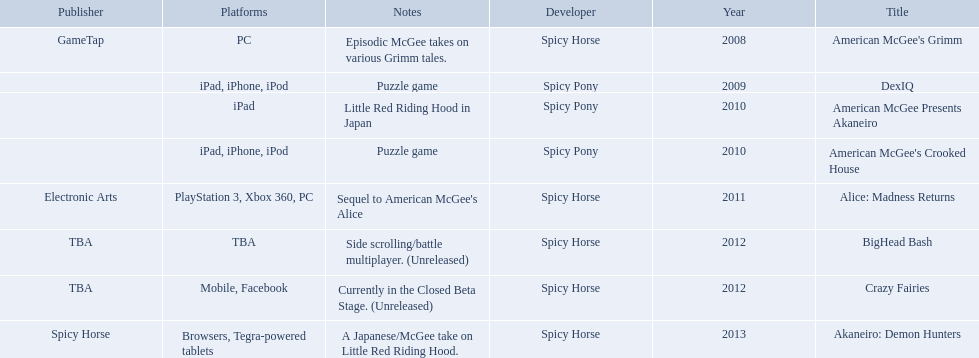What spicy horse titles are listed? American McGee's Grimm, DexIQ, American McGee Presents Akaneiro, American McGee's Crooked House, Alice: Madness Returns, BigHead Bash, Crazy Fairies, Akaneiro: Demon Hunters. Which of these can be used on ipad? DexIQ, American McGee Presents Akaneiro, American McGee's Crooked House. Which left cannot also be used on iphone or ipod? American McGee Presents Akaneiro. 